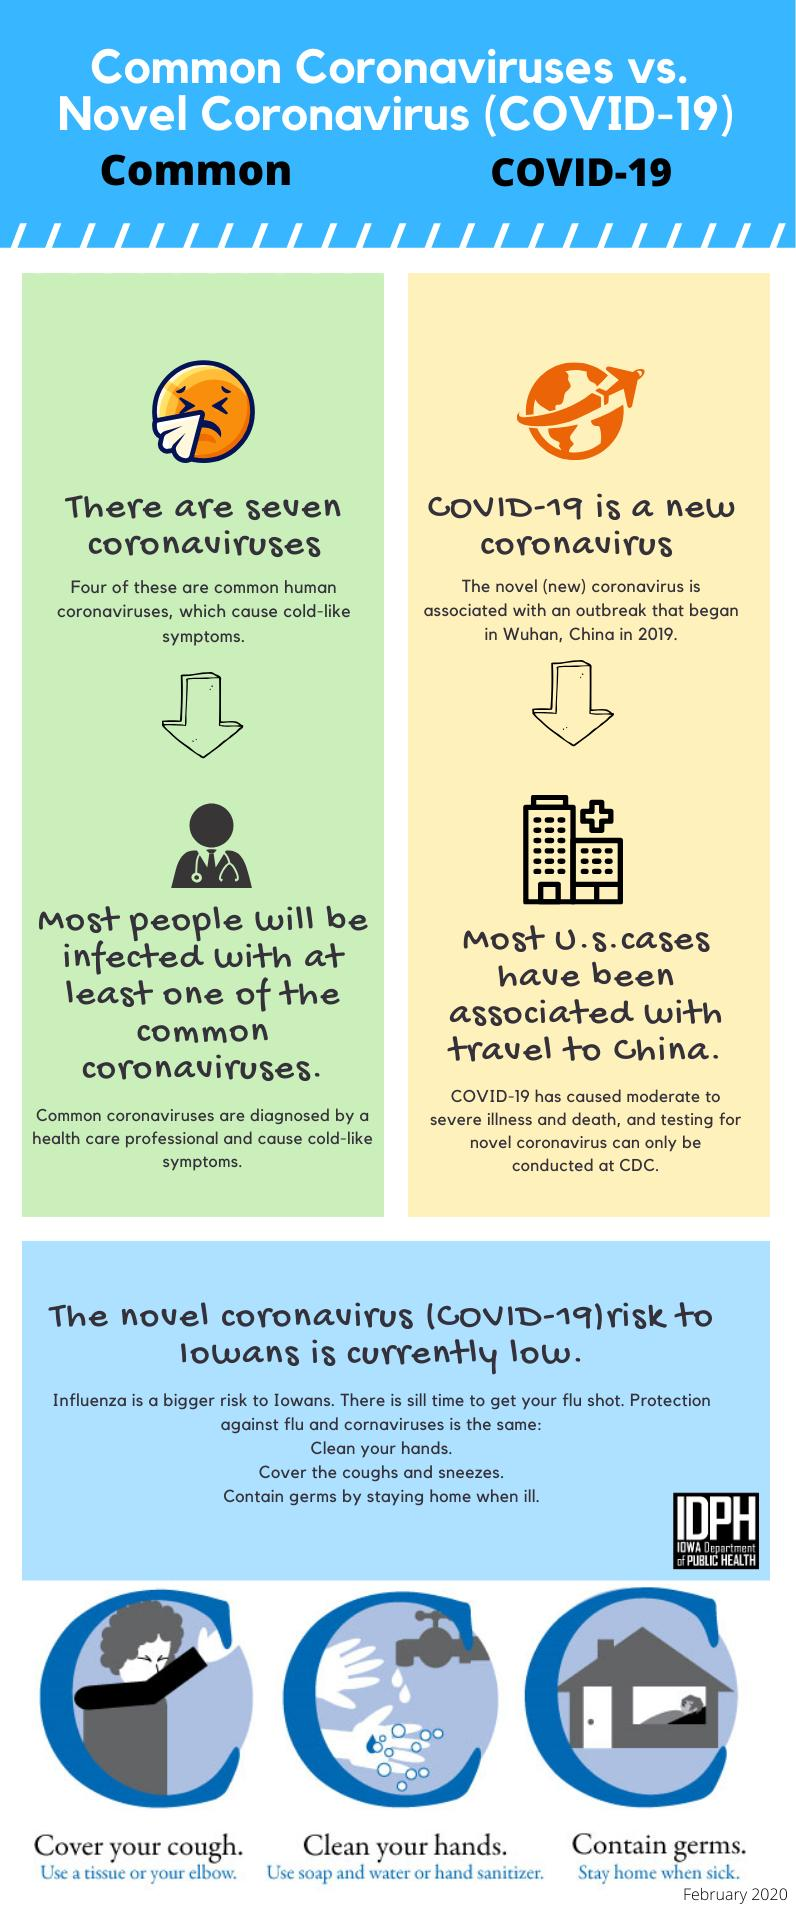Indicate a few pertinent items in this graphic. Out of the 7 common coronavirus types, 3 did not present with cold-like symptoms. 